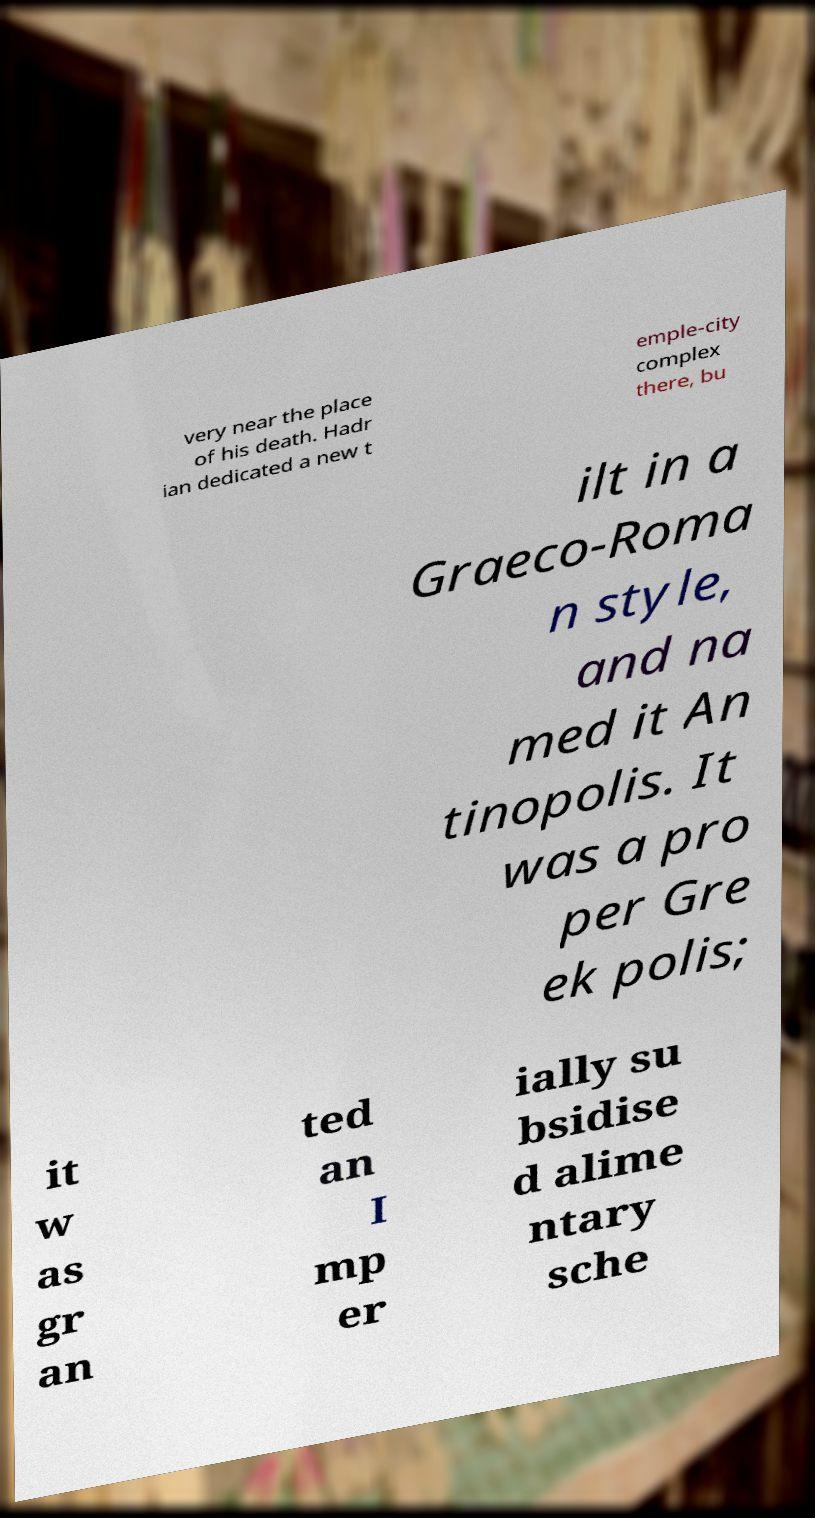For documentation purposes, I need the text within this image transcribed. Could you provide that? very near the place of his death. Hadr ian dedicated a new t emple-city complex there, bu ilt in a Graeco-Roma n style, and na med it An tinopolis. It was a pro per Gre ek polis; it w as gr an ted an I mp er ially su bsidise d alime ntary sche 